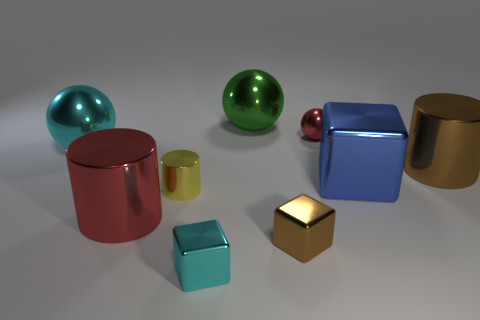Add 1 small yellow shiny things. How many objects exist? 10 Subtract all balls. How many objects are left? 6 Subtract 0 gray cylinders. How many objects are left? 9 Subtract all gray spheres. Subtract all small yellow objects. How many objects are left? 8 Add 5 large blue cubes. How many large blue cubes are left? 6 Add 5 red things. How many red things exist? 7 